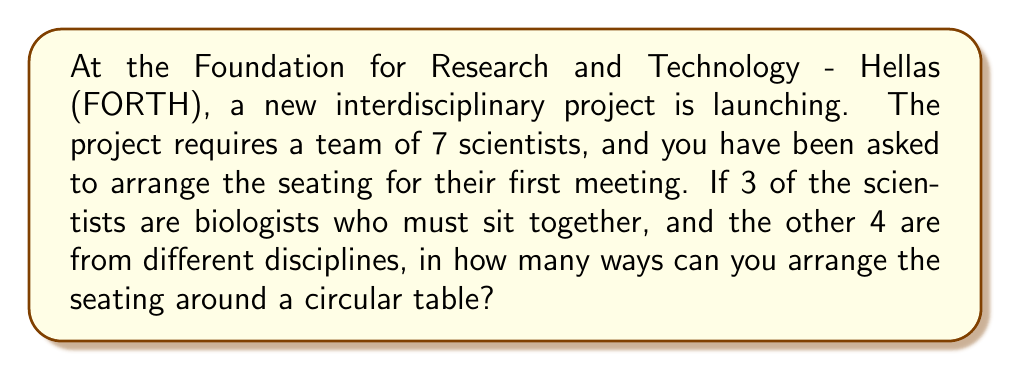Give your solution to this math problem. Let's approach this problem step by step:

1) First, we need to consider the 3 biologists as one unit. So effectively, we are arranging 5 units around the table: the group of biologists and the 4 other scientists.

2) For circular permutations, we can fix one position and arrange the rest. This reduces the problem to a linear permutation of 4 units (as one position is fixed).

3) The number of ways to arrange 4 units linearly is $4!= 4 \times 3 \times 2 \times 1 = 24$.

4) However, we're not done yet. The 3 biologists can also be arranged among themselves in $3! = 6$ ways.

5) By the multiplication principle, we multiply these results:

   $24 \times 6 = 144$

Therefore, the total number of possible arrangements is 144.

To break it down mathematically:

$$\text{Total arrangements} = (n-1)! \times m!$$

Where $n$ is the total number of units (5 in this case: 4 individual scientists + 1 group of biologists), and $m$ is the number of scientists in the group that must sit together (3 biologists).

So, $$(5-1)! \times 3! = 4! \times 3! = 24 \times 6 = 144$$
Answer: 144 possible arrangements 